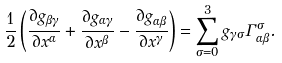Convert formula to latex. <formula><loc_0><loc_0><loc_500><loc_500>\frac { 1 } { 2 } \left ( \frac { \partial g _ { \beta \gamma } } { \partial x ^ { \alpha } } + \frac { \partial g _ { \alpha \gamma } } { \partial x ^ { \beta } } - \frac { \partial g _ { \alpha \beta } } { \partial x ^ { \gamma } } \right ) = \sum _ { \sigma = 0 } ^ { 3 } g _ { \gamma \sigma } \Gamma _ { \alpha \beta } ^ { \sigma } .</formula> 